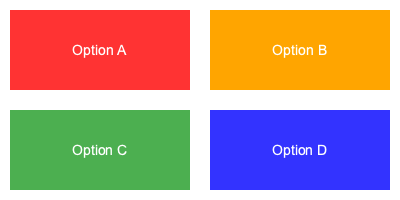Which color combination would be most appropriate for an error message background in a professional software application, considering both visual appeal and user experience? To determine the most appropriate color combination for an error message background, we need to consider several factors:

1. Color psychology: Red is traditionally associated with errors, warnings, and stopping.
2. Contrast: The background color should provide enough contrast for text to be easily readable.
3. Accessibility: The chosen color should be distinguishable for users with color vision deficiencies.
4. Professional appearance: The color should maintain a professional look in a software application.
5. User experience: The color should grab attention without being overly alarming or distracting.

Analyzing the options:
A. Bright red (#FF3333): While red is associated with errors, this shade is too intense and may cause alarm.
B. Orange (#FFA500): Orange is often used for warnings but not typically for errors. It may cause confusion.
C. Green (#4CAF50): Green is generally associated with success or "go" actions, making it inappropriate for errors.
D. Blue (#3333FF): Blue is not typically associated with errors and may not effectively communicate the message.

Considering these factors, the most appropriate choice would be a softer shade of red, which is not provided in the options. Among the given choices, Option A (bright red) is the closest to meeting the criteria, despite being somewhat intense. It maintains the traditional association with errors while providing good contrast for text visibility.
Answer: Option A (Bright Red #FF3333) 